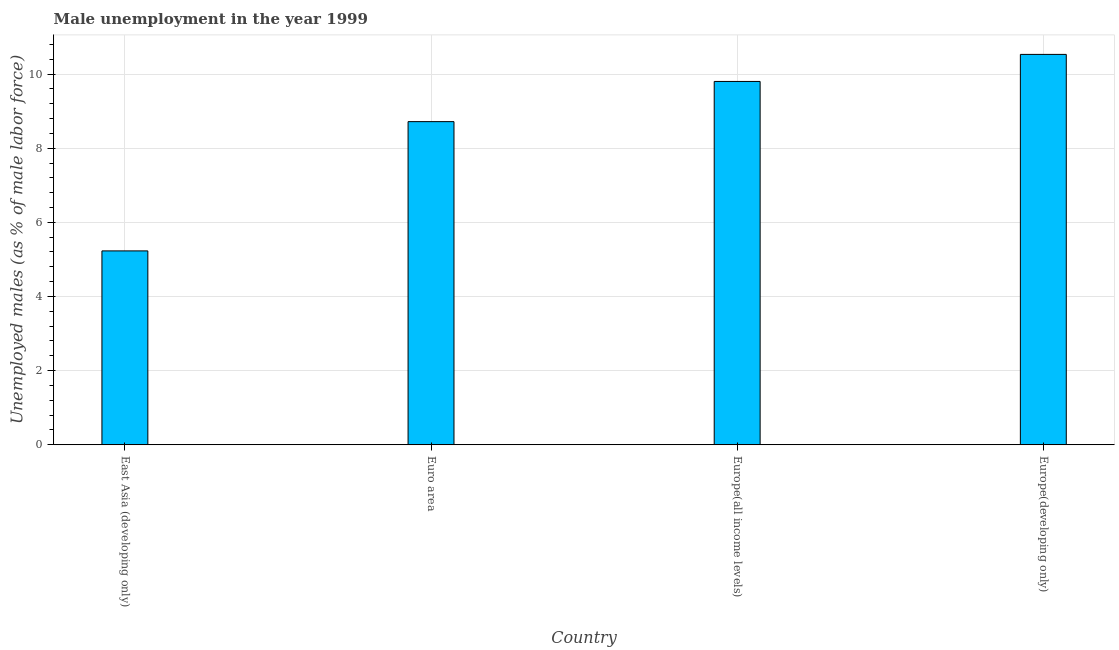Does the graph contain any zero values?
Keep it short and to the point. No. What is the title of the graph?
Your answer should be compact. Male unemployment in the year 1999. What is the label or title of the X-axis?
Your answer should be very brief. Country. What is the label or title of the Y-axis?
Your answer should be very brief. Unemployed males (as % of male labor force). What is the unemployed males population in Europe(developing only)?
Provide a succinct answer. 10.53. Across all countries, what is the maximum unemployed males population?
Your answer should be compact. 10.53. Across all countries, what is the minimum unemployed males population?
Provide a succinct answer. 5.23. In which country was the unemployed males population maximum?
Ensure brevity in your answer.  Europe(developing only). In which country was the unemployed males population minimum?
Make the answer very short. East Asia (developing only). What is the sum of the unemployed males population?
Provide a short and direct response. 34.28. What is the difference between the unemployed males population in East Asia (developing only) and Europe(developing only)?
Offer a very short reply. -5.3. What is the average unemployed males population per country?
Provide a short and direct response. 8.57. What is the median unemployed males population?
Ensure brevity in your answer.  9.26. In how many countries, is the unemployed males population greater than 8 %?
Your response must be concise. 3. What is the ratio of the unemployed males population in East Asia (developing only) to that in Europe(developing only)?
Your response must be concise. 0.5. Is the unemployed males population in East Asia (developing only) less than that in Europe(all income levels)?
Keep it short and to the point. Yes. Is the difference between the unemployed males population in East Asia (developing only) and Europe(all income levels) greater than the difference between any two countries?
Offer a very short reply. No. What is the difference between the highest and the second highest unemployed males population?
Keep it short and to the point. 0.73. Is the sum of the unemployed males population in Euro area and Europe(developing only) greater than the maximum unemployed males population across all countries?
Your response must be concise. Yes. What is the difference between the highest and the lowest unemployed males population?
Provide a succinct answer. 5.3. In how many countries, is the unemployed males population greater than the average unemployed males population taken over all countries?
Provide a succinct answer. 3. How many countries are there in the graph?
Give a very brief answer. 4. What is the Unemployed males (as % of male labor force) in East Asia (developing only)?
Ensure brevity in your answer.  5.23. What is the Unemployed males (as % of male labor force) in Euro area?
Ensure brevity in your answer.  8.72. What is the Unemployed males (as % of male labor force) in Europe(all income levels)?
Provide a short and direct response. 9.8. What is the Unemployed males (as % of male labor force) in Europe(developing only)?
Make the answer very short. 10.53. What is the difference between the Unemployed males (as % of male labor force) in East Asia (developing only) and Euro area?
Your response must be concise. -3.49. What is the difference between the Unemployed males (as % of male labor force) in East Asia (developing only) and Europe(all income levels)?
Provide a short and direct response. -4.57. What is the difference between the Unemployed males (as % of male labor force) in East Asia (developing only) and Europe(developing only)?
Provide a short and direct response. -5.3. What is the difference between the Unemployed males (as % of male labor force) in Euro area and Europe(all income levels)?
Your answer should be compact. -1.08. What is the difference between the Unemployed males (as % of male labor force) in Euro area and Europe(developing only)?
Provide a short and direct response. -1.81. What is the difference between the Unemployed males (as % of male labor force) in Europe(all income levels) and Europe(developing only)?
Offer a very short reply. -0.73. What is the ratio of the Unemployed males (as % of male labor force) in East Asia (developing only) to that in Europe(all income levels)?
Make the answer very short. 0.53. What is the ratio of the Unemployed males (as % of male labor force) in East Asia (developing only) to that in Europe(developing only)?
Offer a terse response. 0.5. What is the ratio of the Unemployed males (as % of male labor force) in Euro area to that in Europe(all income levels)?
Your response must be concise. 0.89. What is the ratio of the Unemployed males (as % of male labor force) in Euro area to that in Europe(developing only)?
Offer a very short reply. 0.83. What is the ratio of the Unemployed males (as % of male labor force) in Europe(all income levels) to that in Europe(developing only)?
Ensure brevity in your answer.  0.93. 